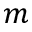<formula> <loc_0><loc_0><loc_500><loc_500>m</formula> 